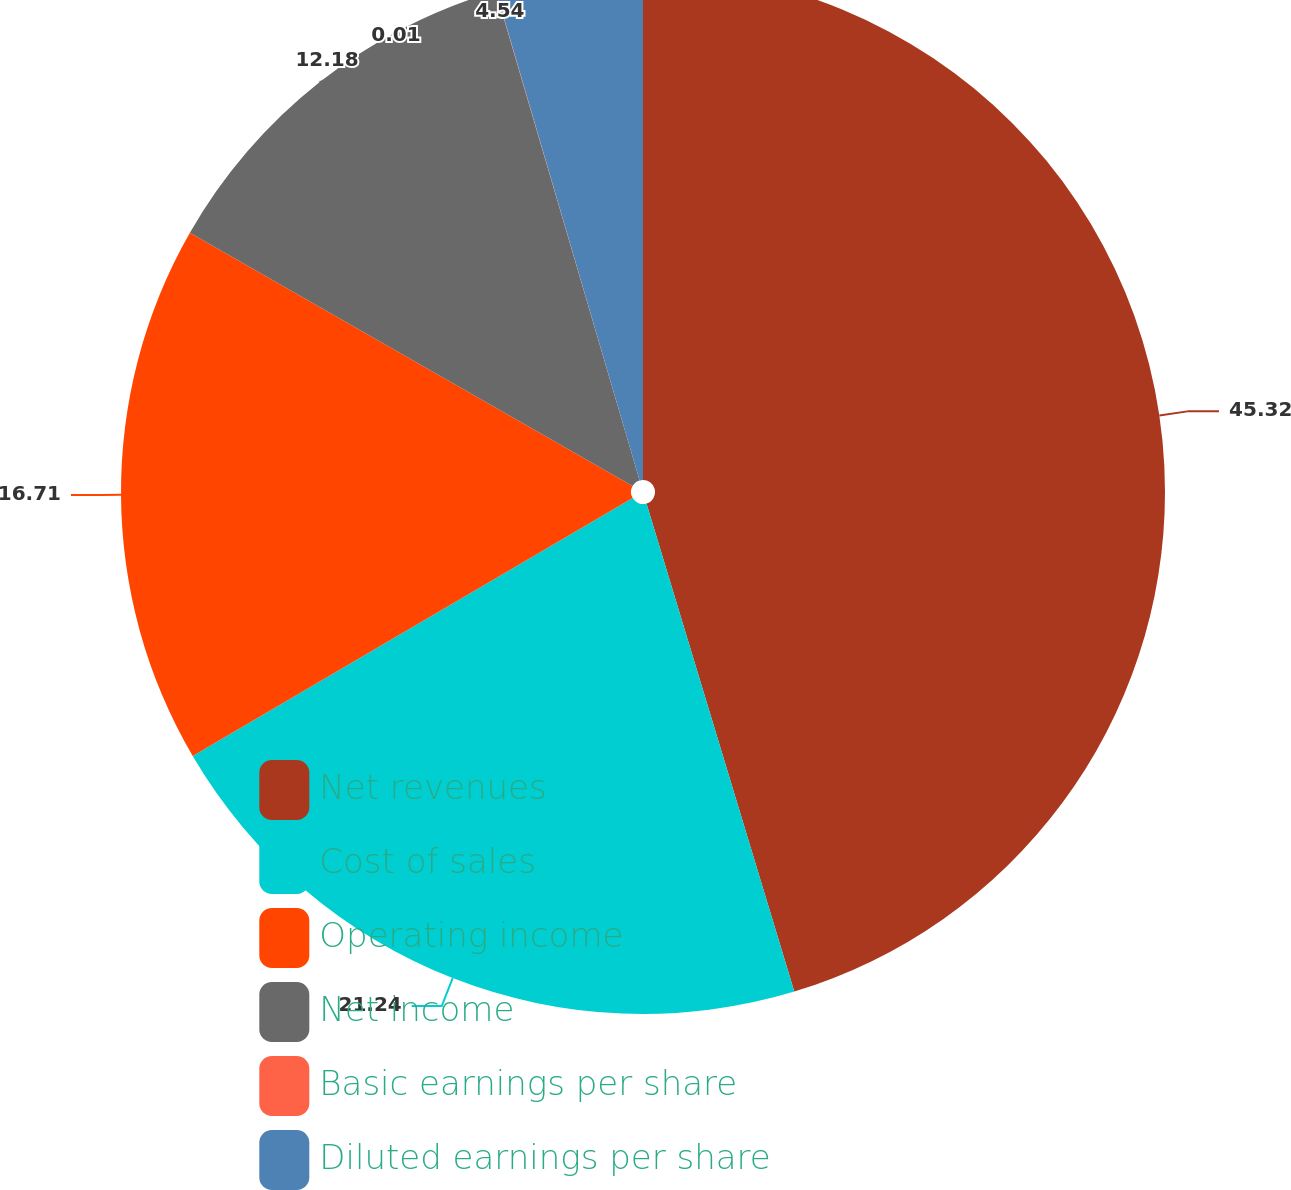<chart> <loc_0><loc_0><loc_500><loc_500><pie_chart><fcel>Net revenues<fcel>Cost of sales<fcel>Operating income<fcel>Net income<fcel>Basic earnings per share<fcel>Diluted earnings per share<nl><fcel>45.32%<fcel>21.24%<fcel>16.71%<fcel>12.18%<fcel>0.01%<fcel>4.54%<nl></chart> 